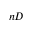<formula> <loc_0><loc_0><loc_500><loc_500>n D</formula> 